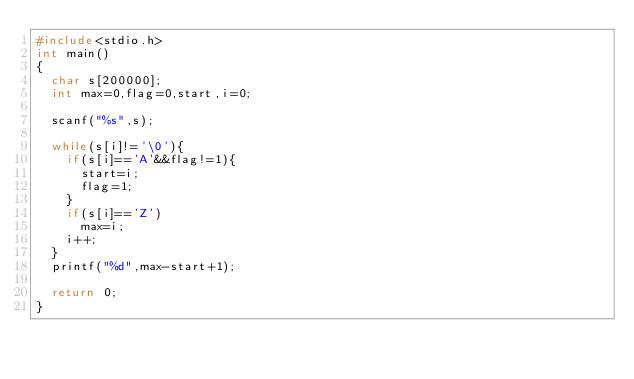Convert code to text. <code><loc_0><loc_0><loc_500><loc_500><_C_>#include<stdio.h>
int main()
{
  char s[200000];
  int max=0,flag=0,start,i=0;
  
  scanf("%s",s);
  
  while(s[i]!='\0'){
    if(s[i]=='A'&&flag!=1){
      start=i;
      flag=1;
    }
    if(s[i]=='Z') 
      max=i;
    i++;
  }
  printf("%d",max-start+1);
  
  return 0;
}</code> 